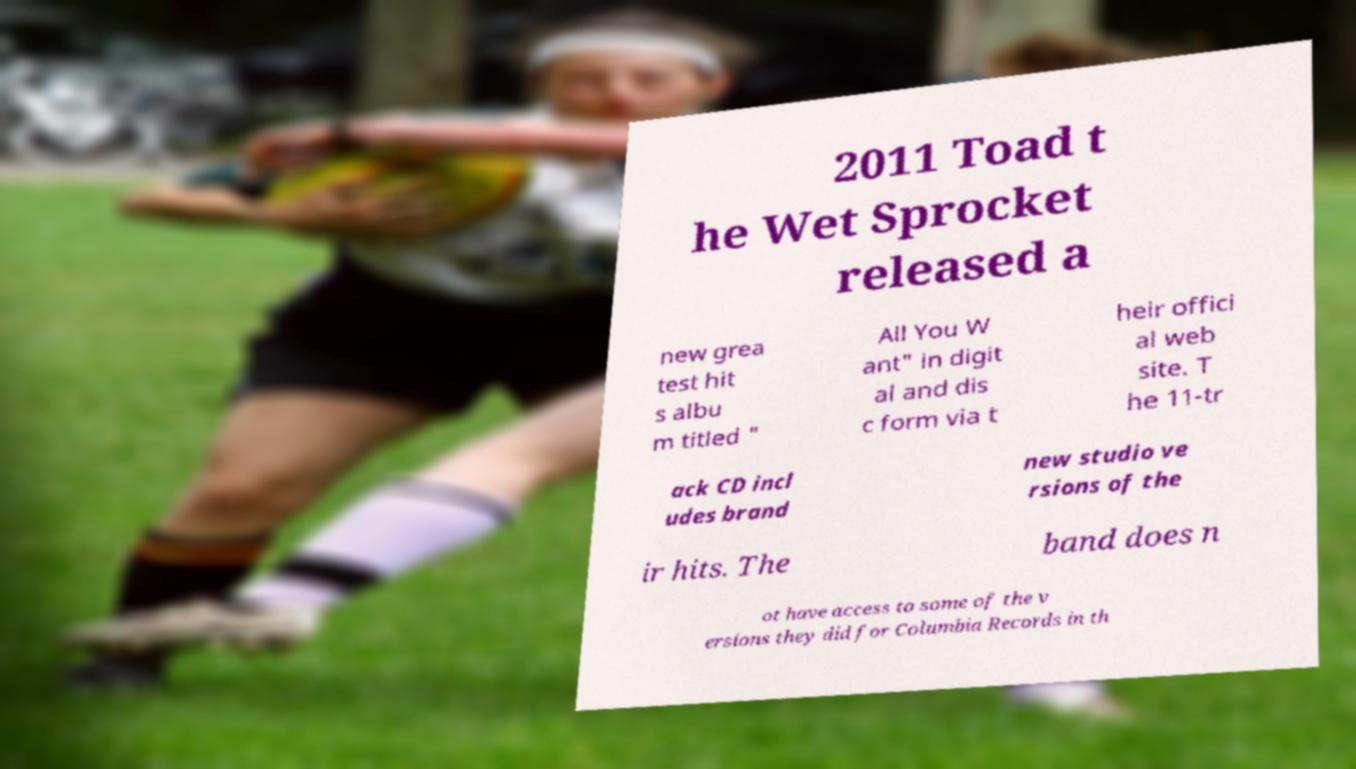I need the written content from this picture converted into text. Can you do that? 2011 Toad t he Wet Sprocket released a new grea test hit s albu m titled " All You W ant" in digit al and dis c form via t heir offici al web site. T he 11-tr ack CD incl udes brand new studio ve rsions of the ir hits. The band does n ot have access to some of the v ersions they did for Columbia Records in th 